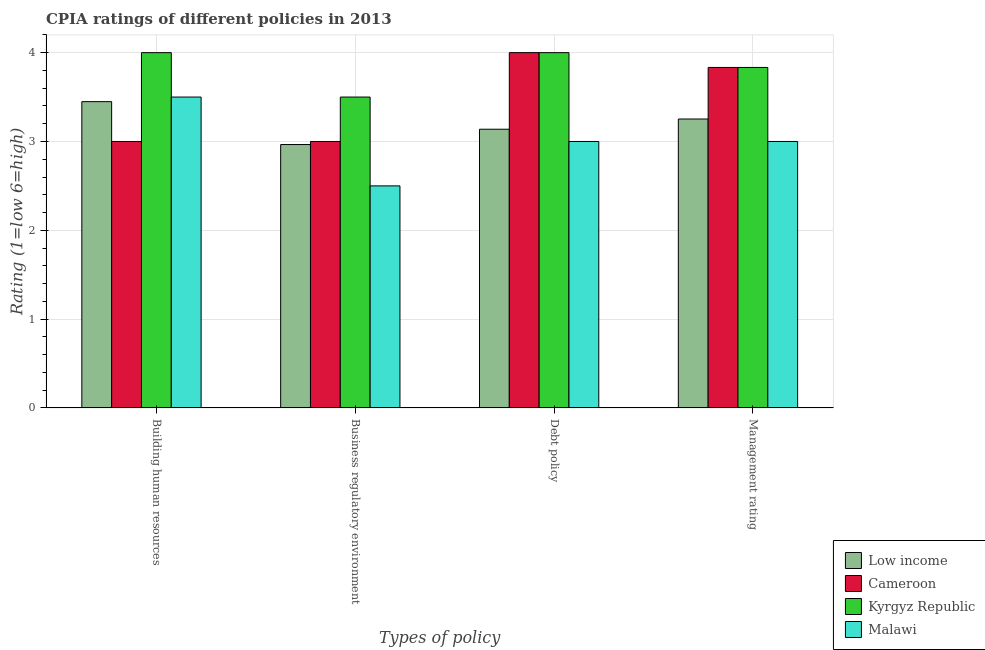Are the number of bars on each tick of the X-axis equal?
Provide a succinct answer. Yes. How many bars are there on the 1st tick from the left?
Provide a succinct answer. 4. What is the label of the 3rd group of bars from the left?
Offer a terse response. Debt policy. Across all countries, what is the maximum cpia rating of management?
Your response must be concise. 3.83. Across all countries, what is the minimum cpia rating of debt policy?
Provide a succinct answer. 3. In which country was the cpia rating of business regulatory environment maximum?
Your answer should be very brief. Kyrgyz Republic. In which country was the cpia rating of business regulatory environment minimum?
Give a very brief answer. Malawi. What is the total cpia rating of building human resources in the graph?
Offer a very short reply. 13.95. What is the difference between the cpia rating of management in Malawi and that in Kyrgyz Republic?
Your answer should be compact. -0.83. What is the difference between the cpia rating of management in Malawi and the cpia rating of business regulatory environment in Kyrgyz Republic?
Make the answer very short. -0.5. What is the average cpia rating of management per country?
Make the answer very short. 3.48. What is the difference between the cpia rating of business regulatory environment and cpia rating of management in Malawi?
Your answer should be compact. -0.5. In how many countries, is the cpia rating of building human resources greater than 0.8 ?
Provide a short and direct response. 4. Is the cpia rating of management in Low income less than that in Malawi?
Keep it short and to the point. No. Is the difference between the cpia rating of building human resources in Malawi and Kyrgyz Republic greater than the difference between the cpia rating of debt policy in Malawi and Kyrgyz Republic?
Your answer should be very brief. Yes. What is the difference between the highest and the second highest cpia rating of debt policy?
Provide a short and direct response. 0. What is the difference between the highest and the lowest cpia rating of management?
Keep it short and to the point. 0.83. In how many countries, is the cpia rating of business regulatory environment greater than the average cpia rating of business regulatory environment taken over all countries?
Give a very brief answer. 2. Is the sum of the cpia rating of building human resources in Malawi and Kyrgyz Republic greater than the maximum cpia rating of business regulatory environment across all countries?
Ensure brevity in your answer.  Yes. What does the 2nd bar from the left in Management rating represents?
Offer a terse response. Cameroon. What does the 4th bar from the right in Debt policy represents?
Give a very brief answer. Low income. Is it the case that in every country, the sum of the cpia rating of building human resources and cpia rating of business regulatory environment is greater than the cpia rating of debt policy?
Your answer should be compact. Yes. Are the values on the major ticks of Y-axis written in scientific E-notation?
Your response must be concise. No. Does the graph contain grids?
Provide a succinct answer. Yes. Where does the legend appear in the graph?
Your answer should be compact. Bottom right. How many legend labels are there?
Ensure brevity in your answer.  4. How are the legend labels stacked?
Your answer should be compact. Vertical. What is the title of the graph?
Ensure brevity in your answer.  CPIA ratings of different policies in 2013. Does "Gabon" appear as one of the legend labels in the graph?
Offer a very short reply. No. What is the label or title of the X-axis?
Offer a very short reply. Types of policy. What is the label or title of the Y-axis?
Your answer should be compact. Rating (1=low 6=high). What is the Rating (1=low 6=high) of Low income in Building human resources?
Give a very brief answer. 3.45. What is the Rating (1=low 6=high) of Cameroon in Building human resources?
Your answer should be compact. 3. What is the Rating (1=low 6=high) in Kyrgyz Republic in Building human resources?
Provide a short and direct response. 4. What is the Rating (1=low 6=high) of Malawi in Building human resources?
Provide a succinct answer. 3.5. What is the Rating (1=low 6=high) of Low income in Business regulatory environment?
Make the answer very short. 2.97. What is the Rating (1=low 6=high) in Low income in Debt policy?
Your answer should be very brief. 3.14. What is the Rating (1=low 6=high) of Cameroon in Debt policy?
Provide a succinct answer. 4. What is the Rating (1=low 6=high) in Malawi in Debt policy?
Ensure brevity in your answer.  3. What is the Rating (1=low 6=high) of Low income in Management rating?
Provide a succinct answer. 3.25. What is the Rating (1=low 6=high) in Cameroon in Management rating?
Keep it short and to the point. 3.83. What is the Rating (1=low 6=high) of Kyrgyz Republic in Management rating?
Your answer should be very brief. 3.83. Across all Types of policy, what is the maximum Rating (1=low 6=high) in Low income?
Provide a short and direct response. 3.45. Across all Types of policy, what is the maximum Rating (1=low 6=high) of Cameroon?
Offer a very short reply. 4. Across all Types of policy, what is the maximum Rating (1=low 6=high) in Kyrgyz Republic?
Offer a terse response. 4. Across all Types of policy, what is the maximum Rating (1=low 6=high) of Malawi?
Your answer should be compact. 3.5. Across all Types of policy, what is the minimum Rating (1=low 6=high) in Low income?
Offer a very short reply. 2.97. Across all Types of policy, what is the minimum Rating (1=low 6=high) in Cameroon?
Provide a short and direct response. 3. What is the total Rating (1=low 6=high) of Low income in the graph?
Provide a succinct answer. 12.8. What is the total Rating (1=low 6=high) of Cameroon in the graph?
Give a very brief answer. 13.83. What is the total Rating (1=low 6=high) in Kyrgyz Republic in the graph?
Offer a very short reply. 15.33. What is the total Rating (1=low 6=high) of Malawi in the graph?
Provide a short and direct response. 12. What is the difference between the Rating (1=low 6=high) of Low income in Building human resources and that in Business regulatory environment?
Make the answer very short. 0.48. What is the difference between the Rating (1=low 6=high) in Kyrgyz Republic in Building human resources and that in Business regulatory environment?
Offer a very short reply. 0.5. What is the difference between the Rating (1=low 6=high) of Malawi in Building human resources and that in Business regulatory environment?
Your response must be concise. 1. What is the difference between the Rating (1=low 6=high) in Low income in Building human resources and that in Debt policy?
Offer a terse response. 0.31. What is the difference between the Rating (1=low 6=high) in Malawi in Building human resources and that in Debt policy?
Make the answer very short. 0.5. What is the difference between the Rating (1=low 6=high) of Low income in Building human resources and that in Management rating?
Ensure brevity in your answer.  0.2. What is the difference between the Rating (1=low 6=high) of Malawi in Building human resources and that in Management rating?
Offer a very short reply. 0.5. What is the difference between the Rating (1=low 6=high) of Low income in Business regulatory environment and that in Debt policy?
Offer a very short reply. -0.17. What is the difference between the Rating (1=low 6=high) in Cameroon in Business regulatory environment and that in Debt policy?
Keep it short and to the point. -1. What is the difference between the Rating (1=low 6=high) of Kyrgyz Republic in Business regulatory environment and that in Debt policy?
Offer a very short reply. -0.5. What is the difference between the Rating (1=low 6=high) in Low income in Business regulatory environment and that in Management rating?
Offer a very short reply. -0.29. What is the difference between the Rating (1=low 6=high) of Kyrgyz Republic in Business regulatory environment and that in Management rating?
Your answer should be compact. -0.33. What is the difference between the Rating (1=low 6=high) of Malawi in Business regulatory environment and that in Management rating?
Provide a short and direct response. -0.5. What is the difference between the Rating (1=low 6=high) in Low income in Debt policy and that in Management rating?
Offer a very short reply. -0.11. What is the difference between the Rating (1=low 6=high) in Kyrgyz Republic in Debt policy and that in Management rating?
Ensure brevity in your answer.  0.17. What is the difference between the Rating (1=low 6=high) of Low income in Building human resources and the Rating (1=low 6=high) of Cameroon in Business regulatory environment?
Your response must be concise. 0.45. What is the difference between the Rating (1=low 6=high) in Low income in Building human resources and the Rating (1=low 6=high) in Kyrgyz Republic in Business regulatory environment?
Make the answer very short. -0.05. What is the difference between the Rating (1=low 6=high) in Low income in Building human resources and the Rating (1=low 6=high) in Malawi in Business regulatory environment?
Your answer should be very brief. 0.95. What is the difference between the Rating (1=low 6=high) in Cameroon in Building human resources and the Rating (1=low 6=high) in Kyrgyz Republic in Business regulatory environment?
Your answer should be compact. -0.5. What is the difference between the Rating (1=low 6=high) of Cameroon in Building human resources and the Rating (1=low 6=high) of Malawi in Business regulatory environment?
Provide a short and direct response. 0.5. What is the difference between the Rating (1=low 6=high) in Low income in Building human resources and the Rating (1=low 6=high) in Cameroon in Debt policy?
Offer a very short reply. -0.55. What is the difference between the Rating (1=low 6=high) in Low income in Building human resources and the Rating (1=low 6=high) in Kyrgyz Republic in Debt policy?
Provide a succinct answer. -0.55. What is the difference between the Rating (1=low 6=high) of Low income in Building human resources and the Rating (1=low 6=high) of Malawi in Debt policy?
Ensure brevity in your answer.  0.45. What is the difference between the Rating (1=low 6=high) of Cameroon in Building human resources and the Rating (1=low 6=high) of Kyrgyz Republic in Debt policy?
Offer a terse response. -1. What is the difference between the Rating (1=low 6=high) in Cameroon in Building human resources and the Rating (1=low 6=high) in Malawi in Debt policy?
Your answer should be compact. 0. What is the difference between the Rating (1=low 6=high) in Kyrgyz Republic in Building human resources and the Rating (1=low 6=high) in Malawi in Debt policy?
Your response must be concise. 1. What is the difference between the Rating (1=low 6=high) in Low income in Building human resources and the Rating (1=low 6=high) in Cameroon in Management rating?
Provide a succinct answer. -0.39. What is the difference between the Rating (1=low 6=high) of Low income in Building human resources and the Rating (1=low 6=high) of Kyrgyz Republic in Management rating?
Make the answer very short. -0.39. What is the difference between the Rating (1=low 6=high) of Low income in Building human resources and the Rating (1=low 6=high) of Malawi in Management rating?
Keep it short and to the point. 0.45. What is the difference between the Rating (1=low 6=high) in Cameroon in Building human resources and the Rating (1=low 6=high) in Kyrgyz Republic in Management rating?
Provide a short and direct response. -0.83. What is the difference between the Rating (1=low 6=high) of Cameroon in Building human resources and the Rating (1=low 6=high) of Malawi in Management rating?
Your answer should be compact. 0. What is the difference between the Rating (1=low 6=high) in Kyrgyz Republic in Building human resources and the Rating (1=low 6=high) in Malawi in Management rating?
Your response must be concise. 1. What is the difference between the Rating (1=low 6=high) of Low income in Business regulatory environment and the Rating (1=low 6=high) of Cameroon in Debt policy?
Keep it short and to the point. -1.03. What is the difference between the Rating (1=low 6=high) of Low income in Business regulatory environment and the Rating (1=low 6=high) of Kyrgyz Republic in Debt policy?
Keep it short and to the point. -1.03. What is the difference between the Rating (1=low 6=high) of Low income in Business regulatory environment and the Rating (1=low 6=high) of Malawi in Debt policy?
Give a very brief answer. -0.03. What is the difference between the Rating (1=low 6=high) of Kyrgyz Republic in Business regulatory environment and the Rating (1=low 6=high) of Malawi in Debt policy?
Give a very brief answer. 0.5. What is the difference between the Rating (1=low 6=high) in Low income in Business regulatory environment and the Rating (1=low 6=high) in Cameroon in Management rating?
Offer a terse response. -0.87. What is the difference between the Rating (1=low 6=high) in Low income in Business regulatory environment and the Rating (1=low 6=high) in Kyrgyz Republic in Management rating?
Make the answer very short. -0.87. What is the difference between the Rating (1=low 6=high) in Low income in Business regulatory environment and the Rating (1=low 6=high) in Malawi in Management rating?
Your answer should be very brief. -0.03. What is the difference between the Rating (1=low 6=high) of Cameroon in Business regulatory environment and the Rating (1=low 6=high) of Kyrgyz Republic in Management rating?
Ensure brevity in your answer.  -0.83. What is the difference between the Rating (1=low 6=high) of Cameroon in Business regulatory environment and the Rating (1=low 6=high) of Malawi in Management rating?
Your answer should be very brief. 0. What is the difference between the Rating (1=low 6=high) in Kyrgyz Republic in Business regulatory environment and the Rating (1=low 6=high) in Malawi in Management rating?
Your answer should be compact. 0.5. What is the difference between the Rating (1=low 6=high) of Low income in Debt policy and the Rating (1=low 6=high) of Cameroon in Management rating?
Your response must be concise. -0.7. What is the difference between the Rating (1=low 6=high) of Low income in Debt policy and the Rating (1=low 6=high) of Kyrgyz Republic in Management rating?
Make the answer very short. -0.7. What is the difference between the Rating (1=low 6=high) of Low income in Debt policy and the Rating (1=low 6=high) of Malawi in Management rating?
Your answer should be compact. 0.14. What is the average Rating (1=low 6=high) in Low income per Types of policy?
Offer a terse response. 3.2. What is the average Rating (1=low 6=high) of Cameroon per Types of policy?
Offer a terse response. 3.46. What is the average Rating (1=low 6=high) of Kyrgyz Republic per Types of policy?
Provide a succinct answer. 3.83. What is the difference between the Rating (1=low 6=high) in Low income and Rating (1=low 6=high) in Cameroon in Building human resources?
Ensure brevity in your answer.  0.45. What is the difference between the Rating (1=low 6=high) in Low income and Rating (1=low 6=high) in Kyrgyz Republic in Building human resources?
Your response must be concise. -0.55. What is the difference between the Rating (1=low 6=high) of Low income and Rating (1=low 6=high) of Malawi in Building human resources?
Give a very brief answer. -0.05. What is the difference between the Rating (1=low 6=high) in Cameroon and Rating (1=low 6=high) in Kyrgyz Republic in Building human resources?
Your answer should be very brief. -1. What is the difference between the Rating (1=low 6=high) of Cameroon and Rating (1=low 6=high) of Malawi in Building human resources?
Provide a succinct answer. -0.5. What is the difference between the Rating (1=low 6=high) in Kyrgyz Republic and Rating (1=low 6=high) in Malawi in Building human resources?
Your answer should be compact. 0.5. What is the difference between the Rating (1=low 6=high) of Low income and Rating (1=low 6=high) of Cameroon in Business regulatory environment?
Offer a terse response. -0.03. What is the difference between the Rating (1=low 6=high) in Low income and Rating (1=low 6=high) in Kyrgyz Republic in Business regulatory environment?
Give a very brief answer. -0.53. What is the difference between the Rating (1=low 6=high) in Low income and Rating (1=low 6=high) in Malawi in Business regulatory environment?
Ensure brevity in your answer.  0.47. What is the difference between the Rating (1=low 6=high) in Cameroon and Rating (1=low 6=high) in Kyrgyz Republic in Business regulatory environment?
Keep it short and to the point. -0.5. What is the difference between the Rating (1=low 6=high) of Cameroon and Rating (1=low 6=high) of Malawi in Business regulatory environment?
Keep it short and to the point. 0.5. What is the difference between the Rating (1=low 6=high) of Kyrgyz Republic and Rating (1=low 6=high) of Malawi in Business regulatory environment?
Your answer should be very brief. 1. What is the difference between the Rating (1=low 6=high) in Low income and Rating (1=low 6=high) in Cameroon in Debt policy?
Offer a very short reply. -0.86. What is the difference between the Rating (1=low 6=high) of Low income and Rating (1=low 6=high) of Kyrgyz Republic in Debt policy?
Make the answer very short. -0.86. What is the difference between the Rating (1=low 6=high) in Low income and Rating (1=low 6=high) in Malawi in Debt policy?
Give a very brief answer. 0.14. What is the difference between the Rating (1=low 6=high) in Cameroon and Rating (1=low 6=high) in Kyrgyz Republic in Debt policy?
Offer a terse response. 0. What is the difference between the Rating (1=low 6=high) of Kyrgyz Republic and Rating (1=low 6=high) of Malawi in Debt policy?
Make the answer very short. 1. What is the difference between the Rating (1=low 6=high) of Low income and Rating (1=low 6=high) of Cameroon in Management rating?
Keep it short and to the point. -0.58. What is the difference between the Rating (1=low 6=high) in Low income and Rating (1=low 6=high) in Kyrgyz Republic in Management rating?
Give a very brief answer. -0.58. What is the difference between the Rating (1=low 6=high) in Low income and Rating (1=low 6=high) in Malawi in Management rating?
Ensure brevity in your answer.  0.25. What is the ratio of the Rating (1=low 6=high) of Low income in Building human resources to that in Business regulatory environment?
Make the answer very short. 1.16. What is the ratio of the Rating (1=low 6=high) in Malawi in Building human resources to that in Business regulatory environment?
Your response must be concise. 1.4. What is the ratio of the Rating (1=low 6=high) of Low income in Building human resources to that in Debt policy?
Give a very brief answer. 1.1. What is the ratio of the Rating (1=low 6=high) in Kyrgyz Republic in Building human resources to that in Debt policy?
Offer a terse response. 1. What is the ratio of the Rating (1=low 6=high) in Low income in Building human resources to that in Management rating?
Offer a terse response. 1.06. What is the ratio of the Rating (1=low 6=high) of Cameroon in Building human resources to that in Management rating?
Offer a very short reply. 0.78. What is the ratio of the Rating (1=low 6=high) of Kyrgyz Republic in Building human resources to that in Management rating?
Your answer should be very brief. 1.04. What is the ratio of the Rating (1=low 6=high) in Low income in Business regulatory environment to that in Debt policy?
Make the answer very short. 0.95. What is the ratio of the Rating (1=low 6=high) of Cameroon in Business regulatory environment to that in Debt policy?
Make the answer very short. 0.75. What is the ratio of the Rating (1=low 6=high) in Kyrgyz Republic in Business regulatory environment to that in Debt policy?
Ensure brevity in your answer.  0.88. What is the ratio of the Rating (1=low 6=high) of Low income in Business regulatory environment to that in Management rating?
Keep it short and to the point. 0.91. What is the ratio of the Rating (1=low 6=high) of Cameroon in Business regulatory environment to that in Management rating?
Offer a terse response. 0.78. What is the ratio of the Rating (1=low 6=high) in Kyrgyz Republic in Business regulatory environment to that in Management rating?
Keep it short and to the point. 0.91. What is the ratio of the Rating (1=low 6=high) of Low income in Debt policy to that in Management rating?
Give a very brief answer. 0.96. What is the ratio of the Rating (1=low 6=high) in Cameroon in Debt policy to that in Management rating?
Your answer should be very brief. 1.04. What is the ratio of the Rating (1=low 6=high) in Kyrgyz Republic in Debt policy to that in Management rating?
Your answer should be compact. 1.04. What is the difference between the highest and the second highest Rating (1=low 6=high) in Low income?
Provide a short and direct response. 0.2. What is the difference between the highest and the second highest Rating (1=low 6=high) in Cameroon?
Keep it short and to the point. 0.17. What is the difference between the highest and the second highest Rating (1=low 6=high) in Kyrgyz Republic?
Offer a very short reply. 0. What is the difference between the highest and the lowest Rating (1=low 6=high) of Low income?
Ensure brevity in your answer.  0.48. 